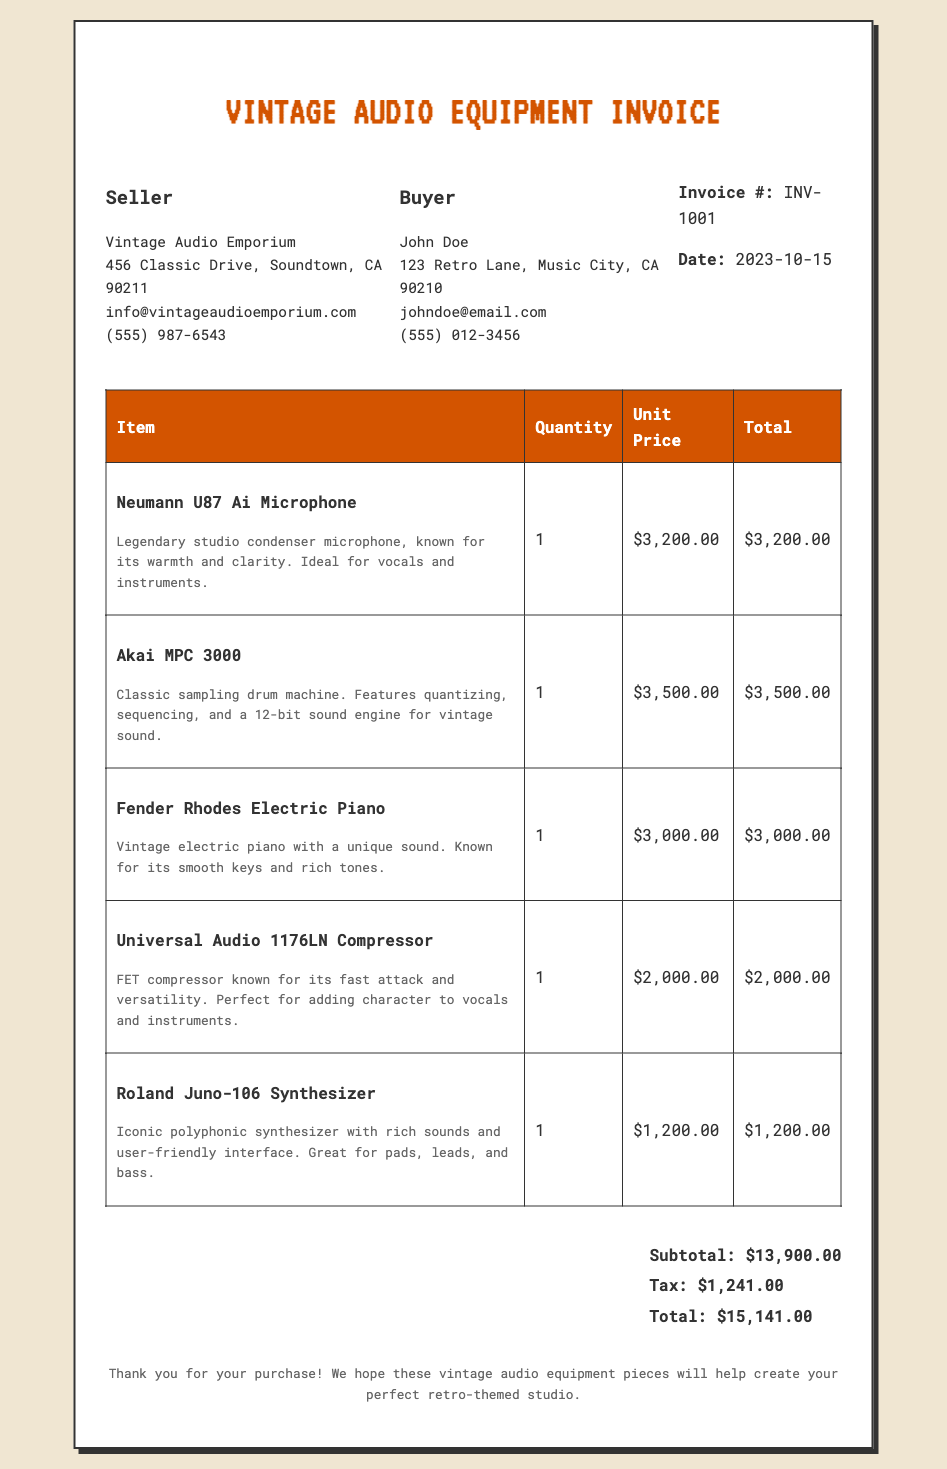What is the invoice number? The invoice number is labeled clearly in the document, which is INV-1001.
Answer: INV-1001 Who is the seller? The seller's name is provided in the document, which is Vintage Audio Emporium.
Answer: Vintage Audio Emporium What is the date of the invoice? The date is mentioned in the document, indicating when the purchase occurred, which is 2023-10-15.
Answer: 2023-10-15 What is the total amount of the invoice? The total amount is calculated as the sum of the subtotal and tax in the document, which is $15,141.00.
Answer: $15,141.00 How many items were purchased? The document lists five items in the purchase, indicating the number of purchased items.
Answer: 5 What is the description of the Neumann U87 Ai Microphone? The description provided in the document details that it is known for its warmth and clarity, suitable for vocals and instruments.
Answer: Legendary studio condenser microphone, known for its warmth and clarity. Ideal for vocals and instruments What is the unit price of the Fender Rhodes Electric Piano? The unit price is specified in the document, as $3,000.00.
Answer: $3,000.00 What is the tax amount listed on the invoice? The tax amount is mentioned under the totals section of the document, which is $1,241.00.
Answer: $1,241.00 Which item has the highest unit price? The item with the highest unit price is identified from the list in the document as the Akai MPC 3000, priced at $3,500.00.
Answer: Akai MPC 3000 